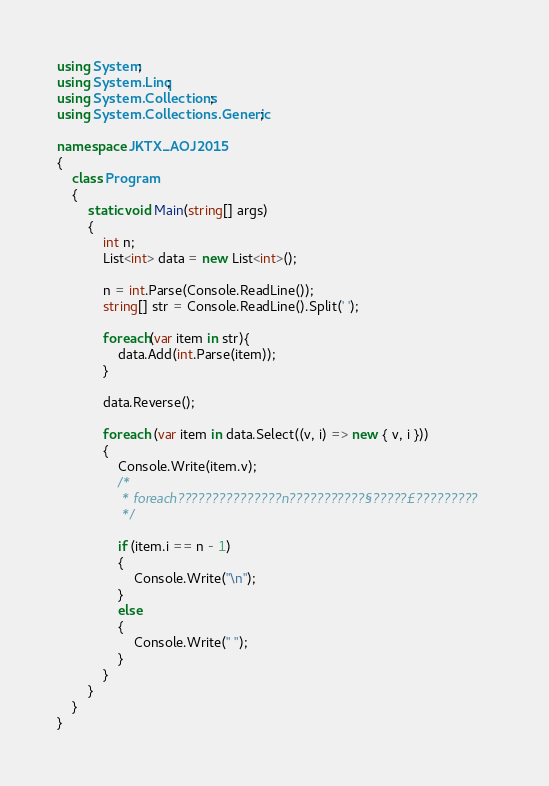Convert code to text. <code><loc_0><loc_0><loc_500><loc_500><_C#_>using System;
using System.Linq;
using System.Collections;
using System.Collections.Generic;

namespace JKTX_AOJ2015
{
    class Program
    {
        static void Main(string[] args)
        {
            int n;
            List<int> data = new List<int>();

            n = int.Parse(Console.ReadLine());
            string[] str = Console.ReadLine().Split(' ');

            foreach(var item in str){
                data.Add(int.Parse(item));
            }

            data.Reverse();

            foreach (var item in data.Select((v, i) => new { v, i }))
            {
                Console.Write(item.v);
                /*
                 * foreach???????????????n???????????§?????£?????????
                 */

                if (item.i == n - 1)
                {
                    Console.Write("\n");
                }
                else
                {
                    Console.Write(" ");
                }
            }
        }
    }
}</code> 